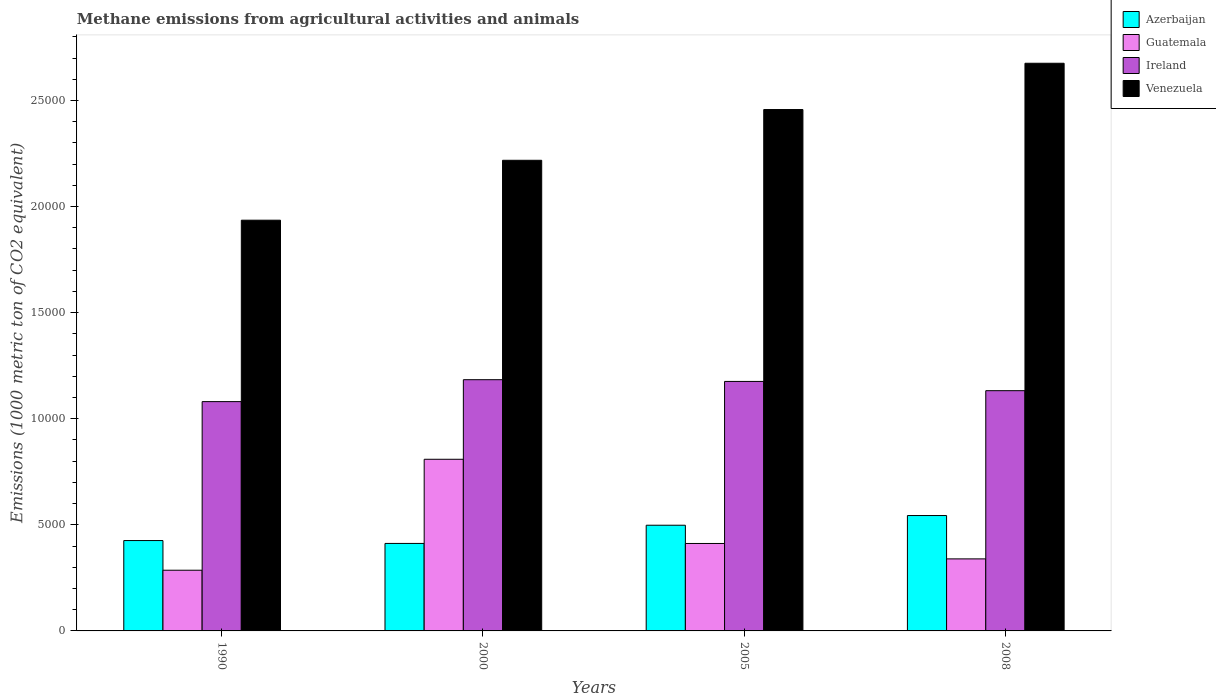How many groups of bars are there?
Make the answer very short. 4. How many bars are there on the 2nd tick from the left?
Keep it short and to the point. 4. What is the label of the 4th group of bars from the left?
Your answer should be compact. 2008. What is the amount of methane emitted in Ireland in 2008?
Provide a succinct answer. 1.13e+04. Across all years, what is the maximum amount of methane emitted in Venezuela?
Your response must be concise. 2.68e+04. Across all years, what is the minimum amount of methane emitted in Ireland?
Offer a terse response. 1.08e+04. In which year was the amount of methane emitted in Azerbaijan maximum?
Provide a succinct answer. 2008. What is the total amount of methane emitted in Ireland in the graph?
Ensure brevity in your answer.  4.57e+04. What is the difference between the amount of methane emitted in Guatemala in 2000 and that in 2005?
Your answer should be compact. 3968.4. What is the difference between the amount of methane emitted in Ireland in 2000 and the amount of methane emitted in Azerbaijan in 2008?
Provide a succinct answer. 6401.5. What is the average amount of methane emitted in Azerbaijan per year?
Keep it short and to the point. 4700.33. In the year 1990, what is the difference between the amount of methane emitted in Ireland and amount of methane emitted in Guatemala?
Give a very brief answer. 7946.3. In how many years, is the amount of methane emitted in Azerbaijan greater than 7000 1000 metric ton?
Give a very brief answer. 0. What is the ratio of the amount of methane emitted in Venezuela in 2005 to that in 2008?
Your answer should be compact. 0.92. Is the difference between the amount of methane emitted in Ireland in 1990 and 2008 greater than the difference between the amount of methane emitted in Guatemala in 1990 and 2008?
Your answer should be compact. Yes. What is the difference between the highest and the second highest amount of methane emitted in Venezuela?
Provide a short and direct response. 2180.8. What is the difference between the highest and the lowest amount of methane emitted in Azerbaijan?
Give a very brief answer. 1314.6. In how many years, is the amount of methane emitted in Guatemala greater than the average amount of methane emitted in Guatemala taken over all years?
Your answer should be compact. 1. Is it the case that in every year, the sum of the amount of methane emitted in Ireland and amount of methane emitted in Guatemala is greater than the sum of amount of methane emitted in Azerbaijan and amount of methane emitted in Venezuela?
Provide a succinct answer. Yes. What does the 4th bar from the left in 2000 represents?
Provide a short and direct response. Venezuela. What does the 3rd bar from the right in 1990 represents?
Your response must be concise. Guatemala. Is it the case that in every year, the sum of the amount of methane emitted in Guatemala and amount of methane emitted in Ireland is greater than the amount of methane emitted in Azerbaijan?
Your answer should be very brief. Yes. How many bars are there?
Give a very brief answer. 16. Are all the bars in the graph horizontal?
Make the answer very short. No. Does the graph contain grids?
Offer a terse response. No. Where does the legend appear in the graph?
Offer a very short reply. Top right. How many legend labels are there?
Give a very brief answer. 4. How are the legend labels stacked?
Make the answer very short. Vertical. What is the title of the graph?
Your answer should be very brief. Methane emissions from agricultural activities and animals. What is the label or title of the X-axis?
Offer a terse response. Years. What is the label or title of the Y-axis?
Offer a very short reply. Emissions (1000 metric ton of CO2 equivalent). What is the Emissions (1000 metric ton of CO2 equivalent) in Azerbaijan in 1990?
Offer a terse response. 4258.7. What is the Emissions (1000 metric ton of CO2 equivalent) of Guatemala in 1990?
Offer a terse response. 2860.2. What is the Emissions (1000 metric ton of CO2 equivalent) in Ireland in 1990?
Provide a succinct answer. 1.08e+04. What is the Emissions (1000 metric ton of CO2 equivalent) in Venezuela in 1990?
Make the answer very short. 1.94e+04. What is the Emissions (1000 metric ton of CO2 equivalent) in Azerbaijan in 2000?
Provide a succinct answer. 4123.5. What is the Emissions (1000 metric ton of CO2 equivalent) of Guatemala in 2000?
Your answer should be very brief. 8089.2. What is the Emissions (1000 metric ton of CO2 equivalent) in Ireland in 2000?
Provide a short and direct response. 1.18e+04. What is the Emissions (1000 metric ton of CO2 equivalent) of Venezuela in 2000?
Your response must be concise. 2.22e+04. What is the Emissions (1000 metric ton of CO2 equivalent) of Azerbaijan in 2005?
Give a very brief answer. 4981. What is the Emissions (1000 metric ton of CO2 equivalent) in Guatemala in 2005?
Ensure brevity in your answer.  4120.8. What is the Emissions (1000 metric ton of CO2 equivalent) in Ireland in 2005?
Your response must be concise. 1.18e+04. What is the Emissions (1000 metric ton of CO2 equivalent) of Venezuela in 2005?
Ensure brevity in your answer.  2.46e+04. What is the Emissions (1000 metric ton of CO2 equivalent) of Azerbaijan in 2008?
Ensure brevity in your answer.  5438.1. What is the Emissions (1000 metric ton of CO2 equivalent) in Guatemala in 2008?
Make the answer very short. 3394.9. What is the Emissions (1000 metric ton of CO2 equivalent) in Ireland in 2008?
Give a very brief answer. 1.13e+04. What is the Emissions (1000 metric ton of CO2 equivalent) of Venezuela in 2008?
Provide a succinct answer. 2.68e+04. Across all years, what is the maximum Emissions (1000 metric ton of CO2 equivalent) in Azerbaijan?
Your answer should be very brief. 5438.1. Across all years, what is the maximum Emissions (1000 metric ton of CO2 equivalent) in Guatemala?
Your answer should be very brief. 8089.2. Across all years, what is the maximum Emissions (1000 metric ton of CO2 equivalent) in Ireland?
Keep it short and to the point. 1.18e+04. Across all years, what is the maximum Emissions (1000 metric ton of CO2 equivalent) in Venezuela?
Give a very brief answer. 2.68e+04. Across all years, what is the minimum Emissions (1000 metric ton of CO2 equivalent) in Azerbaijan?
Your response must be concise. 4123.5. Across all years, what is the minimum Emissions (1000 metric ton of CO2 equivalent) of Guatemala?
Provide a short and direct response. 2860.2. Across all years, what is the minimum Emissions (1000 metric ton of CO2 equivalent) in Ireland?
Offer a very short reply. 1.08e+04. Across all years, what is the minimum Emissions (1000 metric ton of CO2 equivalent) of Venezuela?
Ensure brevity in your answer.  1.94e+04. What is the total Emissions (1000 metric ton of CO2 equivalent) of Azerbaijan in the graph?
Ensure brevity in your answer.  1.88e+04. What is the total Emissions (1000 metric ton of CO2 equivalent) in Guatemala in the graph?
Give a very brief answer. 1.85e+04. What is the total Emissions (1000 metric ton of CO2 equivalent) of Ireland in the graph?
Provide a short and direct response. 4.57e+04. What is the total Emissions (1000 metric ton of CO2 equivalent) in Venezuela in the graph?
Provide a short and direct response. 9.29e+04. What is the difference between the Emissions (1000 metric ton of CO2 equivalent) in Azerbaijan in 1990 and that in 2000?
Your answer should be compact. 135.2. What is the difference between the Emissions (1000 metric ton of CO2 equivalent) in Guatemala in 1990 and that in 2000?
Give a very brief answer. -5229. What is the difference between the Emissions (1000 metric ton of CO2 equivalent) in Ireland in 1990 and that in 2000?
Make the answer very short. -1033.1. What is the difference between the Emissions (1000 metric ton of CO2 equivalent) in Venezuela in 1990 and that in 2000?
Make the answer very short. -2823.3. What is the difference between the Emissions (1000 metric ton of CO2 equivalent) in Azerbaijan in 1990 and that in 2005?
Offer a terse response. -722.3. What is the difference between the Emissions (1000 metric ton of CO2 equivalent) in Guatemala in 1990 and that in 2005?
Provide a short and direct response. -1260.6. What is the difference between the Emissions (1000 metric ton of CO2 equivalent) of Ireland in 1990 and that in 2005?
Offer a very short reply. -951.9. What is the difference between the Emissions (1000 metric ton of CO2 equivalent) of Venezuela in 1990 and that in 2005?
Offer a very short reply. -5215.1. What is the difference between the Emissions (1000 metric ton of CO2 equivalent) of Azerbaijan in 1990 and that in 2008?
Your answer should be very brief. -1179.4. What is the difference between the Emissions (1000 metric ton of CO2 equivalent) of Guatemala in 1990 and that in 2008?
Provide a succinct answer. -534.7. What is the difference between the Emissions (1000 metric ton of CO2 equivalent) in Ireland in 1990 and that in 2008?
Your response must be concise. -516. What is the difference between the Emissions (1000 metric ton of CO2 equivalent) in Venezuela in 1990 and that in 2008?
Your answer should be very brief. -7395.9. What is the difference between the Emissions (1000 metric ton of CO2 equivalent) of Azerbaijan in 2000 and that in 2005?
Your answer should be very brief. -857.5. What is the difference between the Emissions (1000 metric ton of CO2 equivalent) in Guatemala in 2000 and that in 2005?
Keep it short and to the point. 3968.4. What is the difference between the Emissions (1000 metric ton of CO2 equivalent) in Ireland in 2000 and that in 2005?
Your response must be concise. 81.2. What is the difference between the Emissions (1000 metric ton of CO2 equivalent) of Venezuela in 2000 and that in 2005?
Your answer should be compact. -2391.8. What is the difference between the Emissions (1000 metric ton of CO2 equivalent) of Azerbaijan in 2000 and that in 2008?
Provide a short and direct response. -1314.6. What is the difference between the Emissions (1000 metric ton of CO2 equivalent) in Guatemala in 2000 and that in 2008?
Your answer should be very brief. 4694.3. What is the difference between the Emissions (1000 metric ton of CO2 equivalent) in Ireland in 2000 and that in 2008?
Your answer should be very brief. 517.1. What is the difference between the Emissions (1000 metric ton of CO2 equivalent) in Venezuela in 2000 and that in 2008?
Provide a succinct answer. -4572.6. What is the difference between the Emissions (1000 metric ton of CO2 equivalent) in Azerbaijan in 2005 and that in 2008?
Keep it short and to the point. -457.1. What is the difference between the Emissions (1000 metric ton of CO2 equivalent) in Guatemala in 2005 and that in 2008?
Provide a short and direct response. 725.9. What is the difference between the Emissions (1000 metric ton of CO2 equivalent) of Ireland in 2005 and that in 2008?
Your answer should be compact. 435.9. What is the difference between the Emissions (1000 metric ton of CO2 equivalent) in Venezuela in 2005 and that in 2008?
Provide a succinct answer. -2180.8. What is the difference between the Emissions (1000 metric ton of CO2 equivalent) in Azerbaijan in 1990 and the Emissions (1000 metric ton of CO2 equivalent) in Guatemala in 2000?
Provide a succinct answer. -3830.5. What is the difference between the Emissions (1000 metric ton of CO2 equivalent) of Azerbaijan in 1990 and the Emissions (1000 metric ton of CO2 equivalent) of Ireland in 2000?
Your answer should be compact. -7580.9. What is the difference between the Emissions (1000 metric ton of CO2 equivalent) of Azerbaijan in 1990 and the Emissions (1000 metric ton of CO2 equivalent) of Venezuela in 2000?
Your answer should be compact. -1.79e+04. What is the difference between the Emissions (1000 metric ton of CO2 equivalent) of Guatemala in 1990 and the Emissions (1000 metric ton of CO2 equivalent) of Ireland in 2000?
Ensure brevity in your answer.  -8979.4. What is the difference between the Emissions (1000 metric ton of CO2 equivalent) in Guatemala in 1990 and the Emissions (1000 metric ton of CO2 equivalent) in Venezuela in 2000?
Ensure brevity in your answer.  -1.93e+04. What is the difference between the Emissions (1000 metric ton of CO2 equivalent) of Ireland in 1990 and the Emissions (1000 metric ton of CO2 equivalent) of Venezuela in 2000?
Ensure brevity in your answer.  -1.14e+04. What is the difference between the Emissions (1000 metric ton of CO2 equivalent) of Azerbaijan in 1990 and the Emissions (1000 metric ton of CO2 equivalent) of Guatemala in 2005?
Give a very brief answer. 137.9. What is the difference between the Emissions (1000 metric ton of CO2 equivalent) of Azerbaijan in 1990 and the Emissions (1000 metric ton of CO2 equivalent) of Ireland in 2005?
Provide a short and direct response. -7499.7. What is the difference between the Emissions (1000 metric ton of CO2 equivalent) of Azerbaijan in 1990 and the Emissions (1000 metric ton of CO2 equivalent) of Venezuela in 2005?
Give a very brief answer. -2.03e+04. What is the difference between the Emissions (1000 metric ton of CO2 equivalent) in Guatemala in 1990 and the Emissions (1000 metric ton of CO2 equivalent) in Ireland in 2005?
Offer a terse response. -8898.2. What is the difference between the Emissions (1000 metric ton of CO2 equivalent) in Guatemala in 1990 and the Emissions (1000 metric ton of CO2 equivalent) in Venezuela in 2005?
Offer a terse response. -2.17e+04. What is the difference between the Emissions (1000 metric ton of CO2 equivalent) of Ireland in 1990 and the Emissions (1000 metric ton of CO2 equivalent) of Venezuela in 2005?
Your answer should be very brief. -1.38e+04. What is the difference between the Emissions (1000 metric ton of CO2 equivalent) of Azerbaijan in 1990 and the Emissions (1000 metric ton of CO2 equivalent) of Guatemala in 2008?
Give a very brief answer. 863.8. What is the difference between the Emissions (1000 metric ton of CO2 equivalent) in Azerbaijan in 1990 and the Emissions (1000 metric ton of CO2 equivalent) in Ireland in 2008?
Ensure brevity in your answer.  -7063.8. What is the difference between the Emissions (1000 metric ton of CO2 equivalent) in Azerbaijan in 1990 and the Emissions (1000 metric ton of CO2 equivalent) in Venezuela in 2008?
Give a very brief answer. -2.25e+04. What is the difference between the Emissions (1000 metric ton of CO2 equivalent) in Guatemala in 1990 and the Emissions (1000 metric ton of CO2 equivalent) in Ireland in 2008?
Offer a very short reply. -8462.3. What is the difference between the Emissions (1000 metric ton of CO2 equivalent) of Guatemala in 1990 and the Emissions (1000 metric ton of CO2 equivalent) of Venezuela in 2008?
Keep it short and to the point. -2.39e+04. What is the difference between the Emissions (1000 metric ton of CO2 equivalent) of Ireland in 1990 and the Emissions (1000 metric ton of CO2 equivalent) of Venezuela in 2008?
Provide a short and direct response. -1.59e+04. What is the difference between the Emissions (1000 metric ton of CO2 equivalent) of Azerbaijan in 2000 and the Emissions (1000 metric ton of CO2 equivalent) of Guatemala in 2005?
Your response must be concise. 2.7. What is the difference between the Emissions (1000 metric ton of CO2 equivalent) in Azerbaijan in 2000 and the Emissions (1000 metric ton of CO2 equivalent) in Ireland in 2005?
Make the answer very short. -7634.9. What is the difference between the Emissions (1000 metric ton of CO2 equivalent) in Azerbaijan in 2000 and the Emissions (1000 metric ton of CO2 equivalent) in Venezuela in 2005?
Offer a terse response. -2.04e+04. What is the difference between the Emissions (1000 metric ton of CO2 equivalent) of Guatemala in 2000 and the Emissions (1000 metric ton of CO2 equivalent) of Ireland in 2005?
Give a very brief answer. -3669.2. What is the difference between the Emissions (1000 metric ton of CO2 equivalent) of Guatemala in 2000 and the Emissions (1000 metric ton of CO2 equivalent) of Venezuela in 2005?
Make the answer very short. -1.65e+04. What is the difference between the Emissions (1000 metric ton of CO2 equivalent) of Ireland in 2000 and the Emissions (1000 metric ton of CO2 equivalent) of Venezuela in 2005?
Your answer should be compact. -1.27e+04. What is the difference between the Emissions (1000 metric ton of CO2 equivalent) of Azerbaijan in 2000 and the Emissions (1000 metric ton of CO2 equivalent) of Guatemala in 2008?
Provide a short and direct response. 728.6. What is the difference between the Emissions (1000 metric ton of CO2 equivalent) in Azerbaijan in 2000 and the Emissions (1000 metric ton of CO2 equivalent) in Ireland in 2008?
Provide a succinct answer. -7199. What is the difference between the Emissions (1000 metric ton of CO2 equivalent) in Azerbaijan in 2000 and the Emissions (1000 metric ton of CO2 equivalent) in Venezuela in 2008?
Your response must be concise. -2.26e+04. What is the difference between the Emissions (1000 metric ton of CO2 equivalent) of Guatemala in 2000 and the Emissions (1000 metric ton of CO2 equivalent) of Ireland in 2008?
Offer a very short reply. -3233.3. What is the difference between the Emissions (1000 metric ton of CO2 equivalent) of Guatemala in 2000 and the Emissions (1000 metric ton of CO2 equivalent) of Venezuela in 2008?
Keep it short and to the point. -1.87e+04. What is the difference between the Emissions (1000 metric ton of CO2 equivalent) in Ireland in 2000 and the Emissions (1000 metric ton of CO2 equivalent) in Venezuela in 2008?
Offer a terse response. -1.49e+04. What is the difference between the Emissions (1000 metric ton of CO2 equivalent) in Azerbaijan in 2005 and the Emissions (1000 metric ton of CO2 equivalent) in Guatemala in 2008?
Offer a terse response. 1586.1. What is the difference between the Emissions (1000 metric ton of CO2 equivalent) of Azerbaijan in 2005 and the Emissions (1000 metric ton of CO2 equivalent) of Ireland in 2008?
Offer a terse response. -6341.5. What is the difference between the Emissions (1000 metric ton of CO2 equivalent) in Azerbaijan in 2005 and the Emissions (1000 metric ton of CO2 equivalent) in Venezuela in 2008?
Provide a short and direct response. -2.18e+04. What is the difference between the Emissions (1000 metric ton of CO2 equivalent) of Guatemala in 2005 and the Emissions (1000 metric ton of CO2 equivalent) of Ireland in 2008?
Offer a terse response. -7201.7. What is the difference between the Emissions (1000 metric ton of CO2 equivalent) of Guatemala in 2005 and the Emissions (1000 metric ton of CO2 equivalent) of Venezuela in 2008?
Keep it short and to the point. -2.26e+04. What is the difference between the Emissions (1000 metric ton of CO2 equivalent) in Ireland in 2005 and the Emissions (1000 metric ton of CO2 equivalent) in Venezuela in 2008?
Make the answer very short. -1.50e+04. What is the average Emissions (1000 metric ton of CO2 equivalent) in Azerbaijan per year?
Provide a succinct answer. 4700.32. What is the average Emissions (1000 metric ton of CO2 equivalent) of Guatemala per year?
Provide a succinct answer. 4616.27. What is the average Emissions (1000 metric ton of CO2 equivalent) in Ireland per year?
Offer a terse response. 1.14e+04. What is the average Emissions (1000 metric ton of CO2 equivalent) of Venezuela per year?
Offer a terse response. 2.32e+04. In the year 1990, what is the difference between the Emissions (1000 metric ton of CO2 equivalent) of Azerbaijan and Emissions (1000 metric ton of CO2 equivalent) of Guatemala?
Keep it short and to the point. 1398.5. In the year 1990, what is the difference between the Emissions (1000 metric ton of CO2 equivalent) of Azerbaijan and Emissions (1000 metric ton of CO2 equivalent) of Ireland?
Your answer should be compact. -6547.8. In the year 1990, what is the difference between the Emissions (1000 metric ton of CO2 equivalent) in Azerbaijan and Emissions (1000 metric ton of CO2 equivalent) in Venezuela?
Offer a very short reply. -1.51e+04. In the year 1990, what is the difference between the Emissions (1000 metric ton of CO2 equivalent) in Guatemala and Emissions (1000 metric ton of CO2 equivalent) in Ireland?
Ensure brevity in your answer.  -7946.3. In the year 1990, what is the difference between the Emissions (1000 metric ton of CO2 equivalent) in Guatemala and Emissions (1000 metric ton of CO2 equivalent) in Venezuela?
Your answer should be compact. -1.65e+04. In the year 1990, what is the difference between the Emissions (1000 metric ton of CO2 equivalent) of Ireland and Emissions (1000 metric ton of CO2 equivalent) of Venezuela?
Offer a very short reply. -8550.7. In the year 2000, what is the difference between the Emissions (1000 metric ton of CO2 equivalent) of Azerbaijan and Emissions (1000 metric ton of CO2 equivalent) of Guatemala?
Give a very brief answer. -3965.7. In the year 2000, what is the difference between the Emissions (1000 metric ton of CO2 equivalent) of Azerbaijan and Emissions (1000 metric ton of CO2 equivalent) of Ireland?
Offer a very short reply. -7716.1. In the year 2000, what is the difference between the Emissions (1000 metric ton of CO2 equivalent) of Azerbaijan and Emissions (1000 metric ton of CO2 equivalent) of Venezuela?
Offer a very short reply. -1.81e+04. In the year 2000, what is the difference between the Emissions (1000 metric ton of CO2 equivalent) in Guatemala and Emissions (1000 metric ton of CO2 equivalent) in Ireland?
Offer a terse response. -3750.4. In the year 2000, what is the difference between the Emissions (1000 metric ton of CO2 equivalent) of Guatemala and Emissions (1000 metric ton of CO2 equivalent) of Venezuela?
Your answer should be compact. -1.41e+04. In the year 2000, what is the difference between the Emissions (1000 metric ton of CO2 equivalent) of Ireland and Emissions (1000 metric ton of CO2 equivalent) of Venezuela?
Your answer should be very brief. -1.03e+04. In the year 2005, what is the difference between the Emissions (1000 metric ton of CO2 equivalent) of Azerbaijan and Emissions (1000 metric ton of CO2 equivalent) of Guatemala?
Provide a succinct answer. 860.2. In the year 2005, what is the difference between the Emissions (1000 metric ton of CO2 equivalent) of Azerbaijan and Emissions (1000 metric ton of CO2 equivalent) of Ireland?
Your answer should be very brief. -6777.4. In the year 2005, what is the difference between the Emissions (1000 metric ton of CO2 equivalent) of Azerbaijan and Emissions (1000 metric ton of CO2 equivalent) of Venezuela?
Give a very brief answer. -1.96e+04. In the year 2005, what is the difference between the Emissions (1000 metric ton of CO2 equivalent) in Guatemala and Emissions (1000 metric ton of CO2 equivalent) in Ireland?
Offer a terse response. -7637.6. In the year 2005, what is the difference between the Emissions (1000 metric ton of CO2 equivalent) of Guatemala and Emissions (1000 metric ton of CO2 equivalent) of Venezuela?
Provide a short and direct response. -2.05e+04. In the year 2005, what is the difference between the Emissions (1000 metric ton of CO2 equivalent) in Ireland and Emissions (1000 metric ton of CO2 equivalent) in Venezuela?
Offer a very short reply. -1.28e+04. In the year 2008, what is the difference between the Emissions (1000 metric ton of CO2 equivalent) in Azerbaijan and Emissions (1000 metric ton of CO2 equivalent) in Guatemala?
Your answer should be compact. 2043.2. In the year 2008, what is the difference between the Emissions (1000 metric ton of CO2 equivalent) of Azerbaijan and Emissions (1000 metric ton of CO2 equivalent) of Ireland?
Your answer should be very brief. -5884.4. In the year 2008, what is the difference between the Emissions (1000 metric ton of CO2 equivalent) in Azerbaijan and Emissions (1000 metric ton of CO2 equivalent) in Venezuela?
Provide a short and direct response. -2.13e+04. In the year 2008, what is the difference between the Emissions (1000 metric ton of CO2 equivalent) in Guatemala and Emissions (1000 metric ton of CO2 equivalent) in Ireland?
Your answer should be compact. -7927.6. In the year 2008, what is the difference between the Emissions (1000 metric ton of CO2 equivalent) in Guatemala and Emissions (1000 metric ton of CO2 equivalent) in Venezuela?
Provide a succinct answer. -2.34e+04. In the year 2008, what is the difference between the Emissions (1000 metric ton of CO2 equivalent) of Ireland and Emissions (1000 metric ton of CO2 equivalent) of Venezuela?
Give a very brief answer. -1.54e+04. What is the ratio of the Emissions (1000 metric ton of CO2 equivalent) of Azerbaijan in 1990 to that in 2000?
Make the answer very short. 1.03. What is the ratio of the Emissions (1000 metric ton of CO2 equivalent) in Guatemala in 1990 to that in 2000?
Ensure brevity in your answer.  0.35. What is the ratio of the Emissions (1000 metric ton of CO2 equivalent) in Ireland in 1990 to that in 2000?
Your answer should be compact. 0.91. What is the ratio of the Emissions (1000 metric ton of CO2 equivalent) of Venezuela in 1990 to that in 2000?
Offer a terse response. 0.87. What is the ratio of the Emissions (1000 metric ton of CO2 equivalent) of Azerbaijan in 1990 to that in 2005?
Your answer should be compact. 0.85. What is the ratio of the Emissions (1000 metric ton of CO2 equivalent) of Guatemala in 1990 to that in 2005?
Give a very brief answer. 0.69. What is the ratio of the Emissions (1000 metric ton of CO2 equivalent) in Ireland in 1990 to that in 2005?
Offer a terse response. 0.92. What is the ratio of the Emissions (1000 metric ton of CO2 equivalent) of Venezuela in 1990 to that in 2005?
Offer a very short reply. 0.79. What is the ratio of the Emissions (1000 metric ton of CO2 equivalent) in Azerbaijan in 1990 to that in 2008?
Your answer should be compact. 0.78. What is the ratio of the Emissions (1000 metric ton of CO2 equivalent) of Guatemala in 1990 to that in 2008?
Offer a very short reply. 0.84. What is the ratio of the Emissions (1000 metric ton of CO2 equivalent) in Ireland in 1990 to that in 2008?
Offer a terse response. 0.95. What is the ratio of the Emissions (1000 metric ton of CO2 equivalent) of Venezuela in 1990 to that in 2008?
Make the answer very short. 0.72. What is the ratio of the Emissions (1000 metric ton of CO2 equivalent) in Azerbaijan in 2000 to that in 2005?
Give a very brief answer. 0.83. What is the ratio of the Emissions (1000 metric ton of CO2 equivalent) of Guatemala in 2000 to that in 2005?
Your answer should be very brief. 1.96. What is the ratio of the Emissions (1000 metric ton of CO2 equivalent) in Venezuela in 2000 to that in 2005?
Your answer should be very brief. 0.9. What is the ratio of the Emissions (1000 metric ton of CO2 equivalent) in Azerbaijan in 2000 to that in 2008?
Offer a very short reply. 0.76. What is the ratio of the Emissions (1000 metric ton of CO2 equivalent) of Guatemala in 2000 to that in 2008?
Your answer should be very brief. 2.38. What is the ratio of the Emissions (1000 metric ton of CO2 equivalent) of Ireland in 2000 to that in 2008?
Give a very brief answer. 1.05. What is the ratio of the Emissions (1000 metric ton of CO2 equivalent) in Venezuela in 2000 to that in 2008?
Make the answer very short. 0.83. What is the ratio of the Emissions (1000 metric ton of CO2 equivalent) in Azerbaijan in 2005 to that in 2008?
Offer a very short reply. 0.92. What is the ratio of the Emissions (1000 metric ton of CO2 equivalent) in Guatemala in 2005 to that in 2008?
Your answer should be very brief. 1.21. What is the ratio of the Emissions (1000 metric ton of CO2 equivalent) of Venezuela in 2005 to that in 2008?
Provide a short and direct response. 0.92. What is the difference between the highest and the second highest Emissions (1000 metric ton of CO2 equivalent) of Azerbaijan?
Your answer should be compact. 457.1. What is the difference between the highest and the second highest Emissions (1000 metric ton of CO2 equivalent) of Guatemala?
Give a very brief answer. 3968.4. What is the difference between the highest and the second highest Emissions (1000 metric ton of CO2 equivalent) of Ireland?
Keep it short and to the point. 81.2. What is the difference between the highest and the second highest Emissions (1000 metric ton of CO2 equivalent) in Venezuela?
Ensure brevity in your answer.  2180.8. What is the difference between the highest and the lowest Emissions (1000 metric ton of CO2 equivalent) of Azerbaijan?
Keep it short and to the point. 1314.6. What is the difference between the highest and the lowest Emissions (1000 metric ton of CO2 equivalent) of Guatemala?
Offer a terse response. 5229. What is the difference between the highest and the lowest Emissions (1000 metric ton of CO2 equivalent) in Ireland?
Your answer should be compact. 1033.1. What is the difference between the highest and the lowest Emissions (1000 metric ton of CO2 equivalent) in Venezuela?
Provide a succinct answer. 7395.9. 